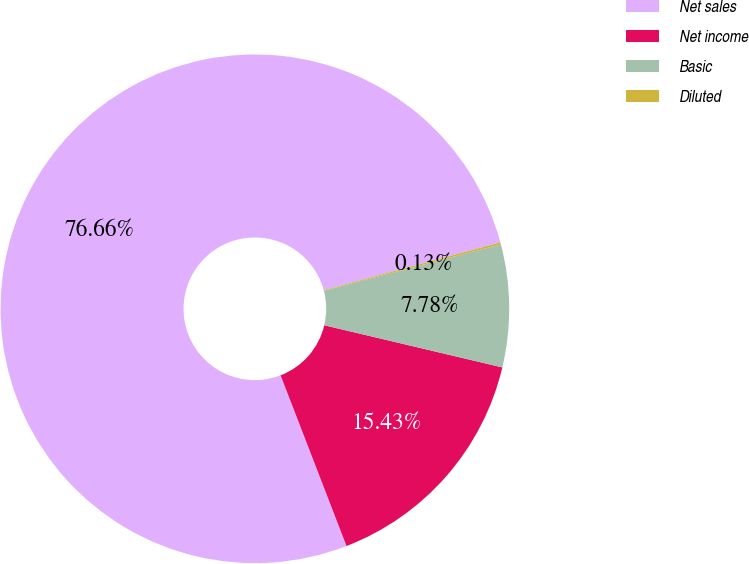Convert chart. <chart><loc_0><loc_0><loc_500><loc_500><pie_chart><fcel>Net sales<fcel>Net income<fcel>Basic<fcel>Diluted<nl><fcel>76.65%<fcel>15.43%<fcel>7.78%<fcel>0.13%<nl></chart> 